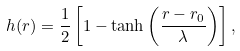Convert formula to latex. <formula><loc_0><loc_0><loc_500><loc_500>h ( r ) = \frac { 1 } { 2 } \left [ 1 - \tanh \left ( \frac { r - r _ { 0 } } { \lambda } \right ) \right ] ,</formula> 